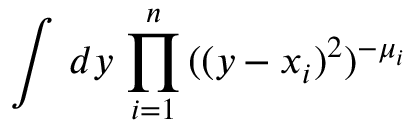<formula> <loc_0><loc_0><loc_500><loc_500>\int \, d y \, \prod _ { i = 1 } ^ { n } \, ( ( y - x _ { i } ) ^ { 2 } ) ^ { - \mu _ { i } }</formula> 